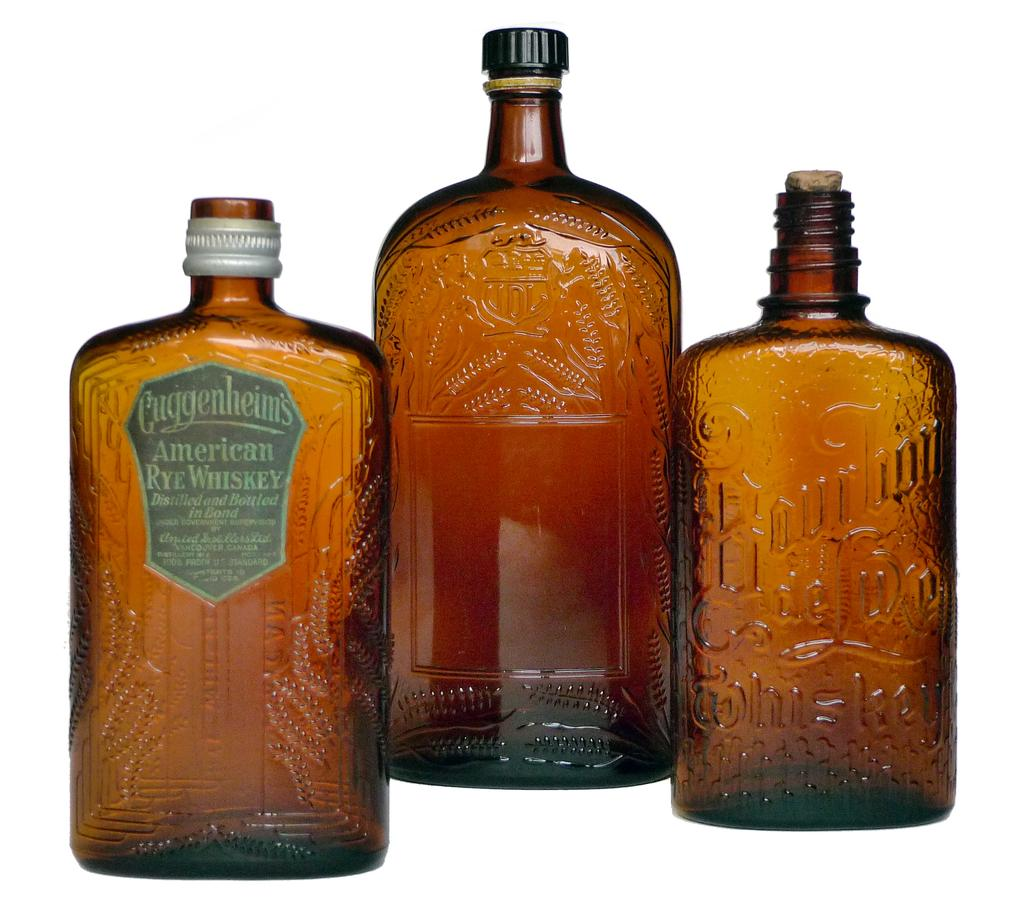<image>
Give a short and clear explanation of the subsequent image. Three brown bottles with the first advertising American Rye Whiskey. 